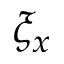Convert formula to latex. <formula><loc_0><loc_0><loc_500><loc_500>\xi _ { x }</formula> 